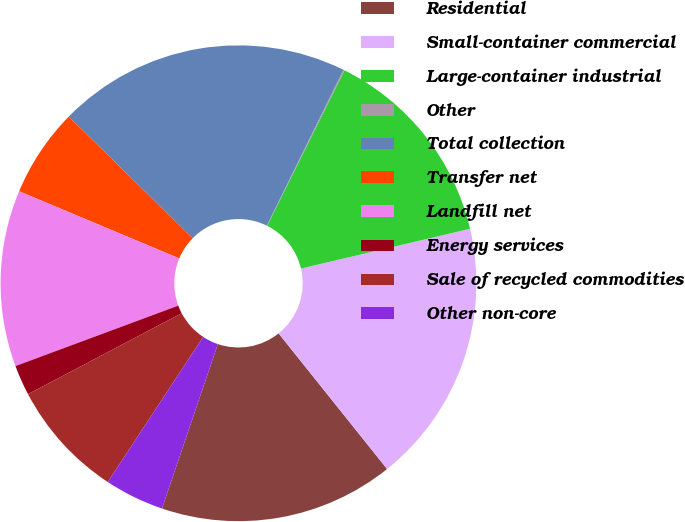Convert chart. <chart><loc_0><loc_0><loc_500><loc_500><pie_chart><fcel>Residential<fcel>Small-container commercial<fcel>Large-container industrial<fcel>Other<fcel>Total collection<fcel>Transfer net<fcel>Landfill net<fcel>Energy services<fcel>Sale of recycled commodities<fcel>Other non-core<nl><fcel>15.95%<fcel>17.94%<fcel>13.97%<fcel>0.08%<fcel>19.92%<fcel>6.03%<fcel>11.98%<fcel>2.06%<fcel>8.02%<fcel>4.05%<nl></chart> 